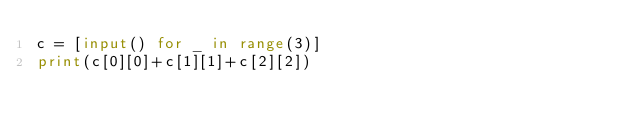Convert code to text. <code><loc_0><loc_0><loc_500><loc_500><_Python_>c = [input() for _ in range(3)]
print(c[0][0]+c[1][1]+c[2][2])
</code> 